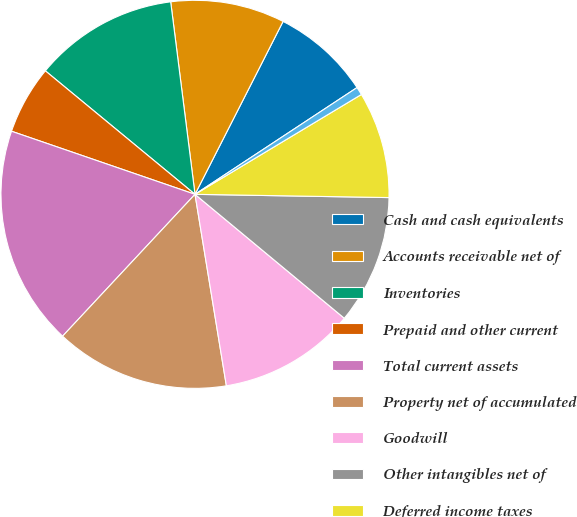Convert chart. <chart><loc_0><loc_0><loc_500><loc_500><pie_chart><fcel>Cash and cash equivalents<fcel>Accounts receivable net of<fcel>Inventories<fcel>Prepaid and other current<fcel>Total current assets<fcel>Property net of accumulated<fcel>Goodwill<fcel>Other intangibles net of<fcel>Deferred income taxes<fcel>Other noncurrent assets<nl><fcel>8.23%<fcel>9.5%<fcel>12.02%<fcel>5.71%<fcel>18.32%<fcel>14.54%<fcel>11.39%<fcel>10.76%<fcel>8.87%<fcel>0.67%<nl></chart> 